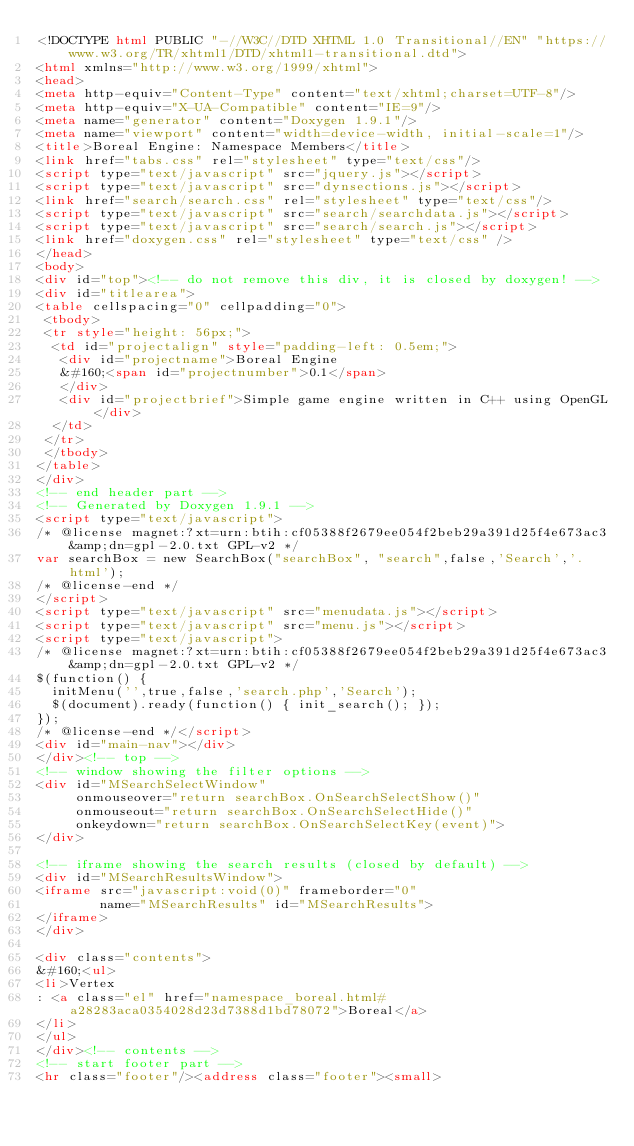Convert code to text. <code><loc_0><loc_0><loc_500><loc_500><_HTML_><!DOCTYPE html PUBLIC "-//W3C//DTD XHTML 1.0 Transitional//EN" "https://www.w3.org/TR/xhtml1/DTD/xhtml1-transitional.dtd">
<html xmlns="http://www.w3.org/1999/xhtml">
<head>
<meta http-equiv="Content-Type" content="text/xhtml;charset=UTF-8"/>
<meta http-equiv="X-UA-Compatible" content="IE=9"/>
<meta name="generator" content="Doxygen 1.9.1"/>
<meta name="viewport" content="width=device-width, initial-scale=1"/>
<title>Boreal Engine: Namespace Members</title>
<link href="tabs.css" rel="stylesheet" type="text/css"/>
<script type="text/javascript" src="jquery.js"></script>
<script type="text/javascript" src="dynsections.js"></script>
<link href="search/search.css" rel="stylesheet" type="text/css"/>
<script type="text/javascript" src="search/searchdata.js"></script>
<script type="text/javascript" src="search/search.js"></script>
<link href="doxygen.css" rel="stylesheet" type="text/css" />
</head>
<body>
<div id="top"><!-- do not remove this div, it is closed by doxygen! -->
<div id="titlearea">
<table cellspacing="0" cellpadding="0">
 <tbody>
 <tr style="height: 56px;">
  <td id="projectalign" style="padding-left: 0.5em;">
   <div id="projectname">Boreal Engine
   &#160;<span id="projectnumber">0.1</span>
   </div>
   <div id="projectbrief">Simple game engine written in C++ using OpenGL</div>
  </td>
 </tr>
 </tbody>
</table>
</div>
<!-- end header part -->
<!-- Generated by Doxygen 1.9.1 -->
<script type="text/javascript">
/* @license magnet:?xt=urn:btih:cf05388f2679ee054f2beb29a391d25f4e673ac3&amp;dn=gpl-2.0.txt GPL-v2 */
var searchBox = new SearchBox("searchBox", "search",false,'Search','.html');
/* @license-end */
</script>
<script type="text/javascript" src="menudata.js"></script>
<script type="text/javascript" src="menu.js"></script>
<script type="text/javascript">
/* @license magnet:?xt=urn:btih:cf05388f2679ee054f2beb29a391d25f4e673ac3&amp;dn=gpl-2.0.txt GPL-v2 */
$(function() {
  initMenu('',true,false,'search.php','Search');
  $(document).ready(function() { init_search(); });
});
/* @license-end */</script>
<div id="main-nav"></div>
</div><!-- top -->
<!-- window showing the filter options -->
<div id="MSearchSelectWindow"
     onmouseover="return searchBox.OnSearchSelectShow()"
     onmouseout="return searchBox.OnSearchSelectHide()"
     onkeydown="return searchBox.OnSearchSelectKey(event)">
</div>

<!-- iframe showing the search results (closed by default) -->
<div id="MSearchResultsWindow">
<iframe src="javascript:void(0)" frameborder="0" 
        name="MSearchResults" id="MSearchResults">
</iframe>
</div>

<div class="contents">
&#160;<ul>
<li>Vertex
: <a class="el" href="namespace_boreal.html#a28283aca0354028d23d7388d1bd78072">Boreal</a>
</li>
</ul>
</div><!-- contents -->
<!-- start footer part -->
<hr class="footer"/><address class="footer"><small></code> 